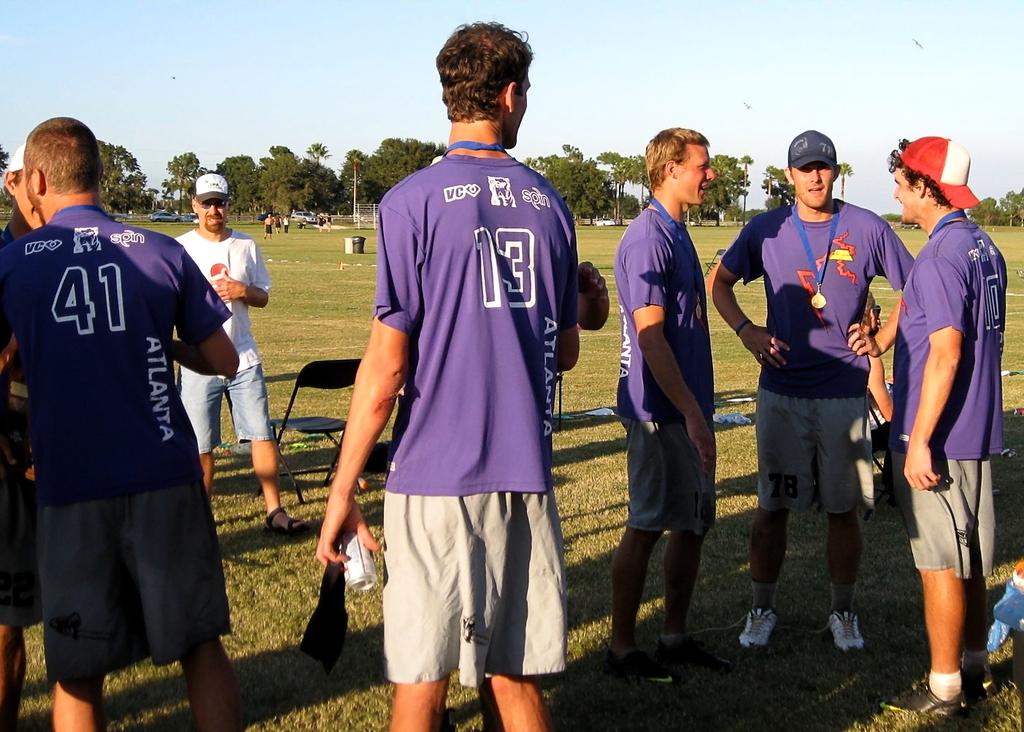What is the jersey number of the player to the left?
Provide a succinct answer. 41. 